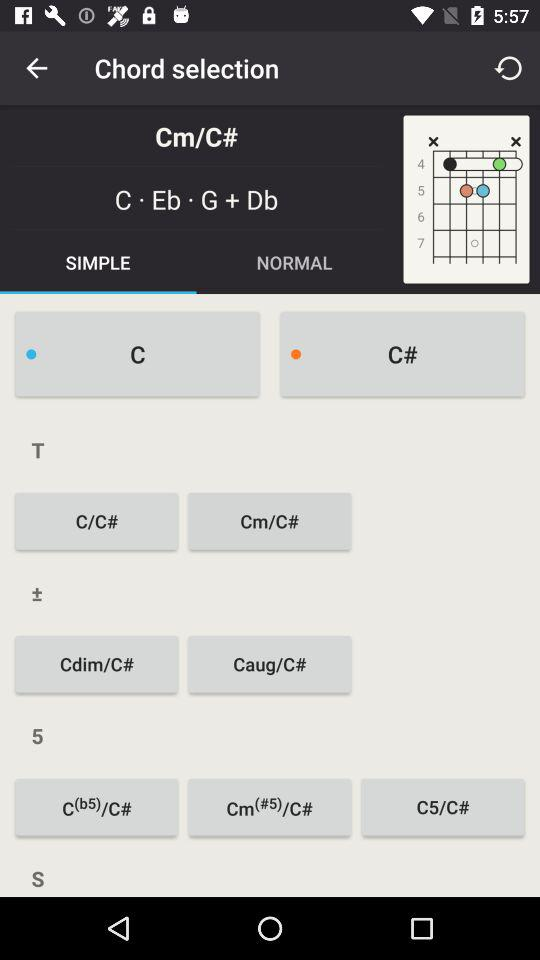Which tab is selected? The selected tab is "SIMPLE". 